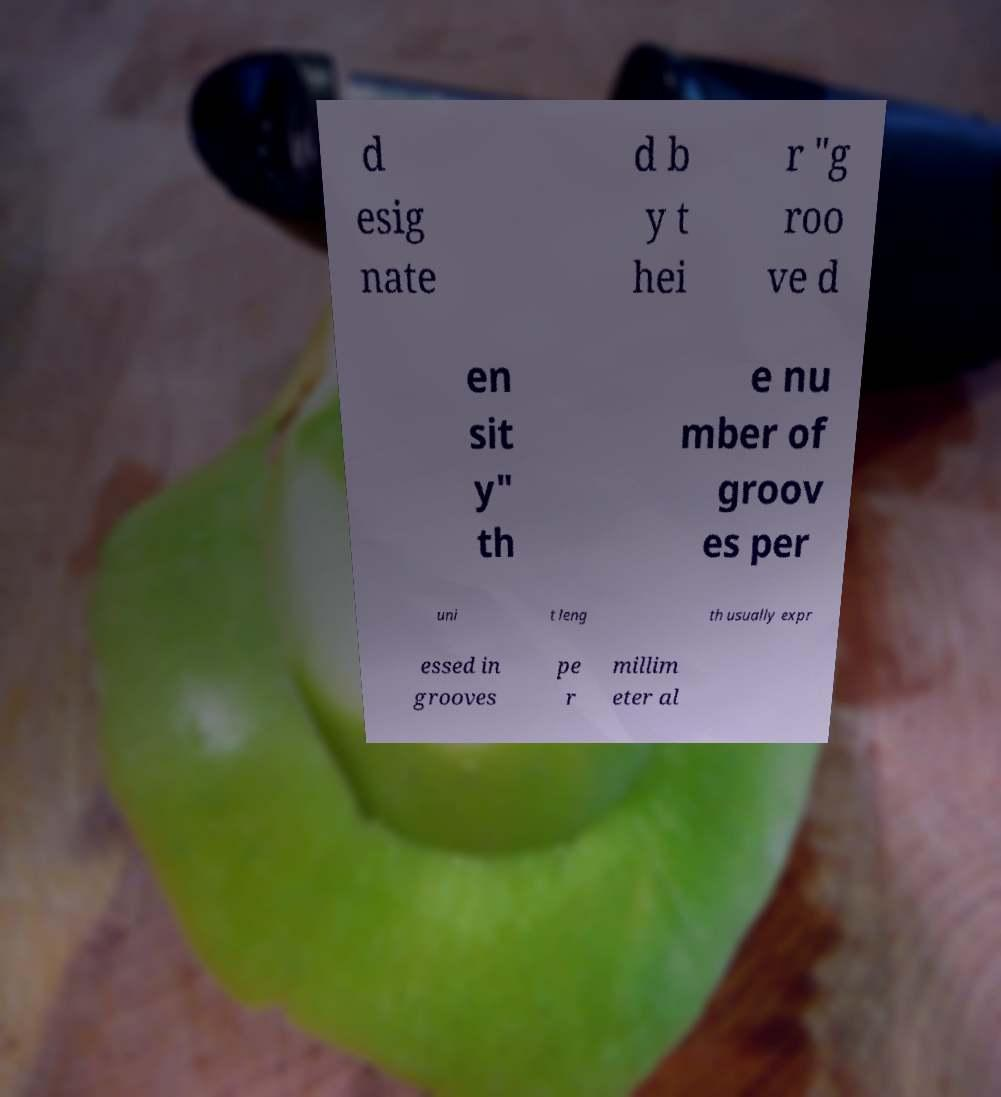Can you read and provide the text displayed in the image?This photo seems to have some interesting text. Can you extract and type it out for me? d esig nate d b y t hei r "g roo ve d en sit y" th e nu mber of groov es per uni t leng th usually expr essed in grooves pe r millim eter al 